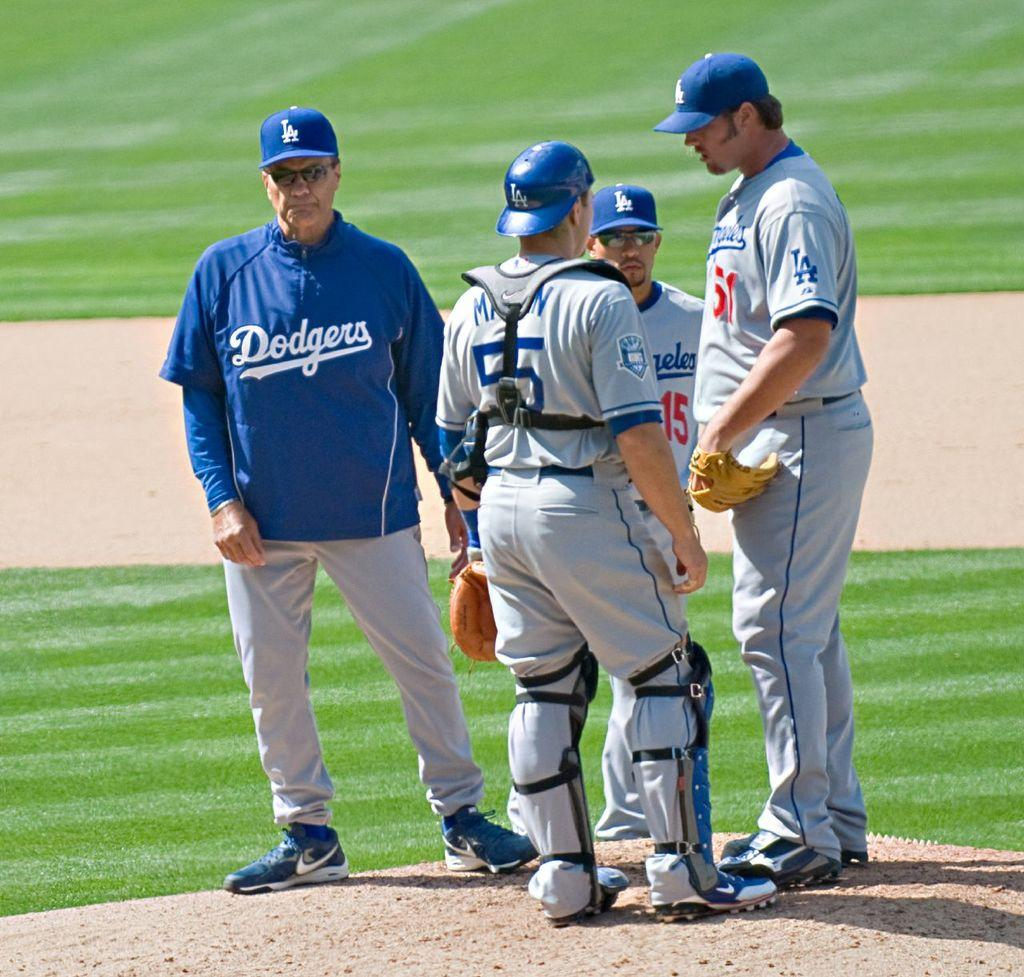<image>
Present a compact description of the photo's key features. Players huddling on a pictures mound  and the manager has a Jacket that says Dogers. 